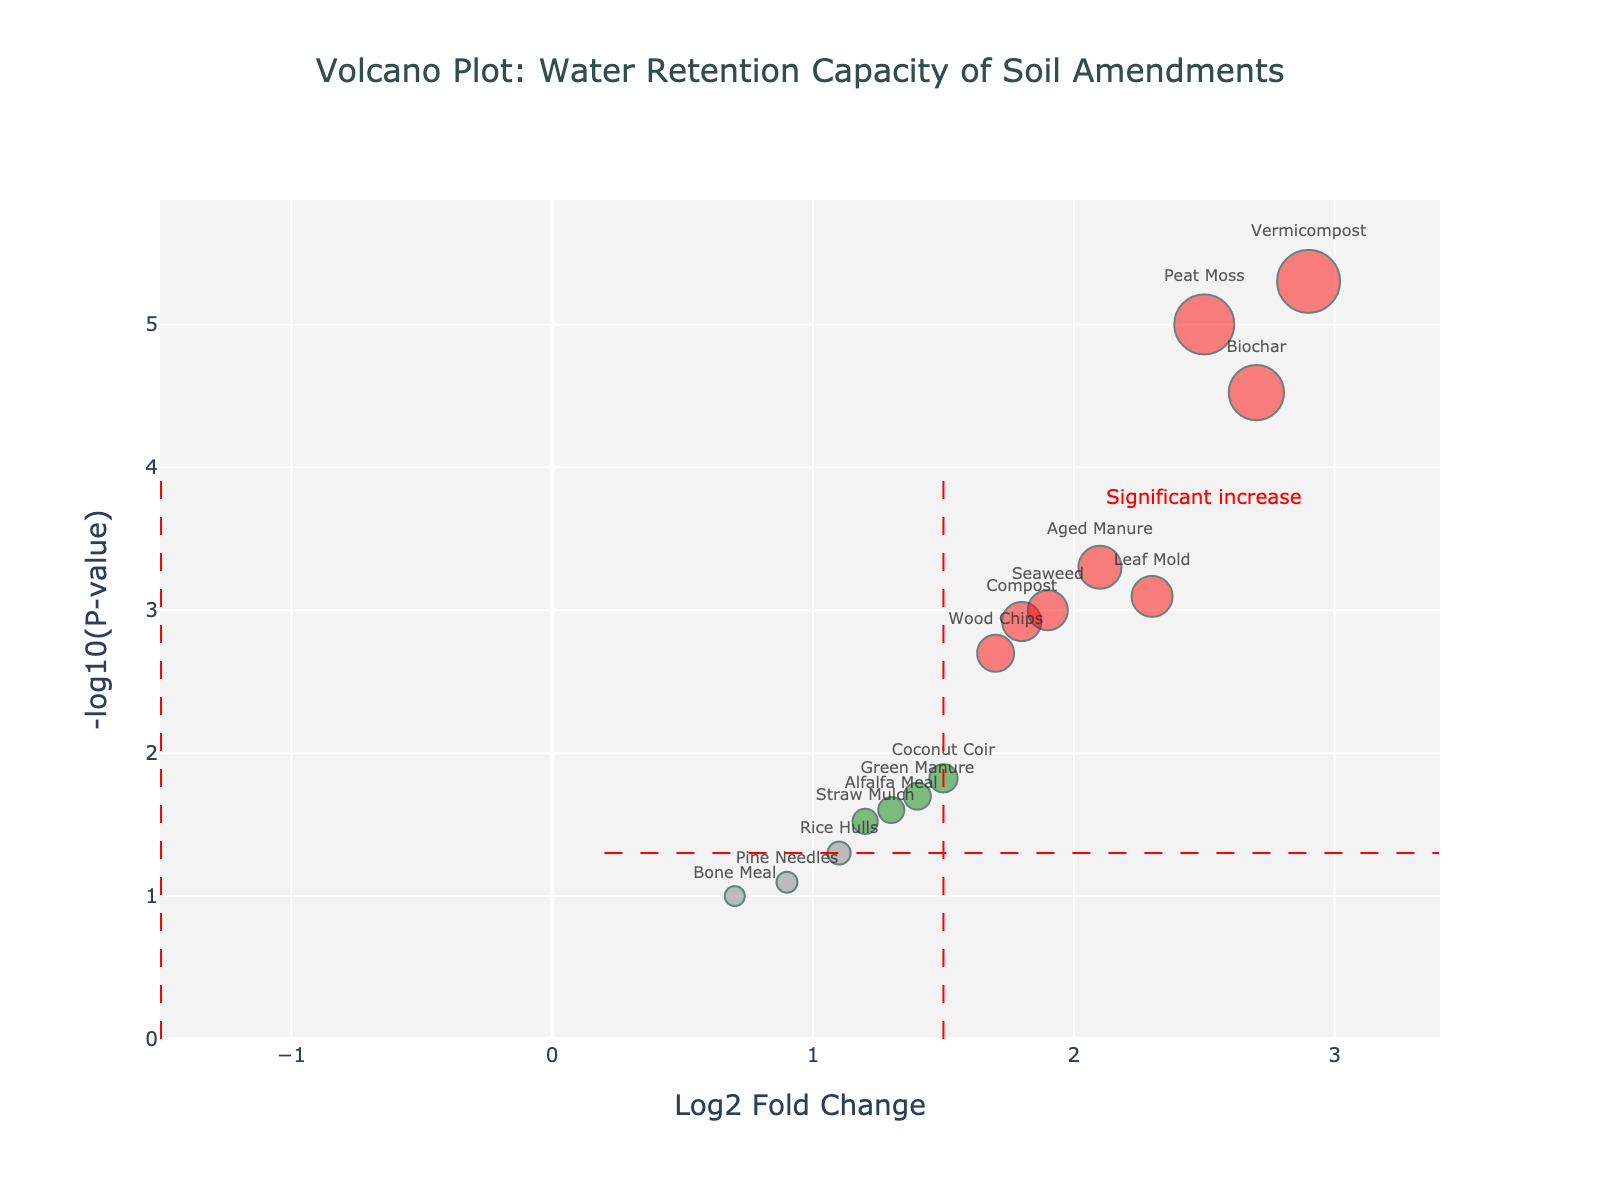What is the title of the figure? The title is located at the top of the figure and clearly states the subject of the plot.
Answer: Volcano Plot: Water Retention Capacity of Soil Amendments How many amendments have a Log2 Fold Change greater than 2? Count the data points on the x-axis (Log2FC) greater than 2. These are Biochar, Peat Moss, and Vermicompost.
Answer: 3 Which soil amendment has the lowest p-value? The data point with the highest y-value (-log10(p-value)) represents the lowest p-value. This is Biochar.
Answer: Biochar What are the x-axis and y-axis titles? The x-axis title is at the bottom and the y-axis title on the left side of the plot. The x-axis title is "Log2 Fold Change" and the y-axis title is "-log10(P-value)".
Answer: Log2 Fold Change and -log10(P-value) Which soil amendment appears to have the smallest effect on water retention capacity based on Log2 Fold Change and p-value? The point with the lowest Log2 Fold Change and a non-significant p-value (p-value > 0.05) is Bone Meal.
Answer: Bone Meal Which amendments are considered significantly impactful based on the given thresholds? Identify amendments on the right side of the red vertical threshold line (Log2FC > 1.5) and above the red horizontal threshold line (-log10(p-value) > 1.3). These include Compost, Leaf Mold, Biochar, Coconut Coir, Aged Manure, Wood Chips, Peat Moss, Vermicompost, Green Manure, Seaweed, and Alfalfa Meal.
Answer: 11 Which amendment has both a moderate Log2 Fold Change (~1.5) and a relatively significant p-value (< 0.05)? The amendment that fits this range includes Coconut Coir with a Log2 Fold Change close to 1.5 and a p-value of 0.015.
Answer: Coconut Coir What annotations or additional information is highlighted on the plot? The annotations include an added text "Significant increase" near the upper right region of the plot.
Answer: Significant increase 